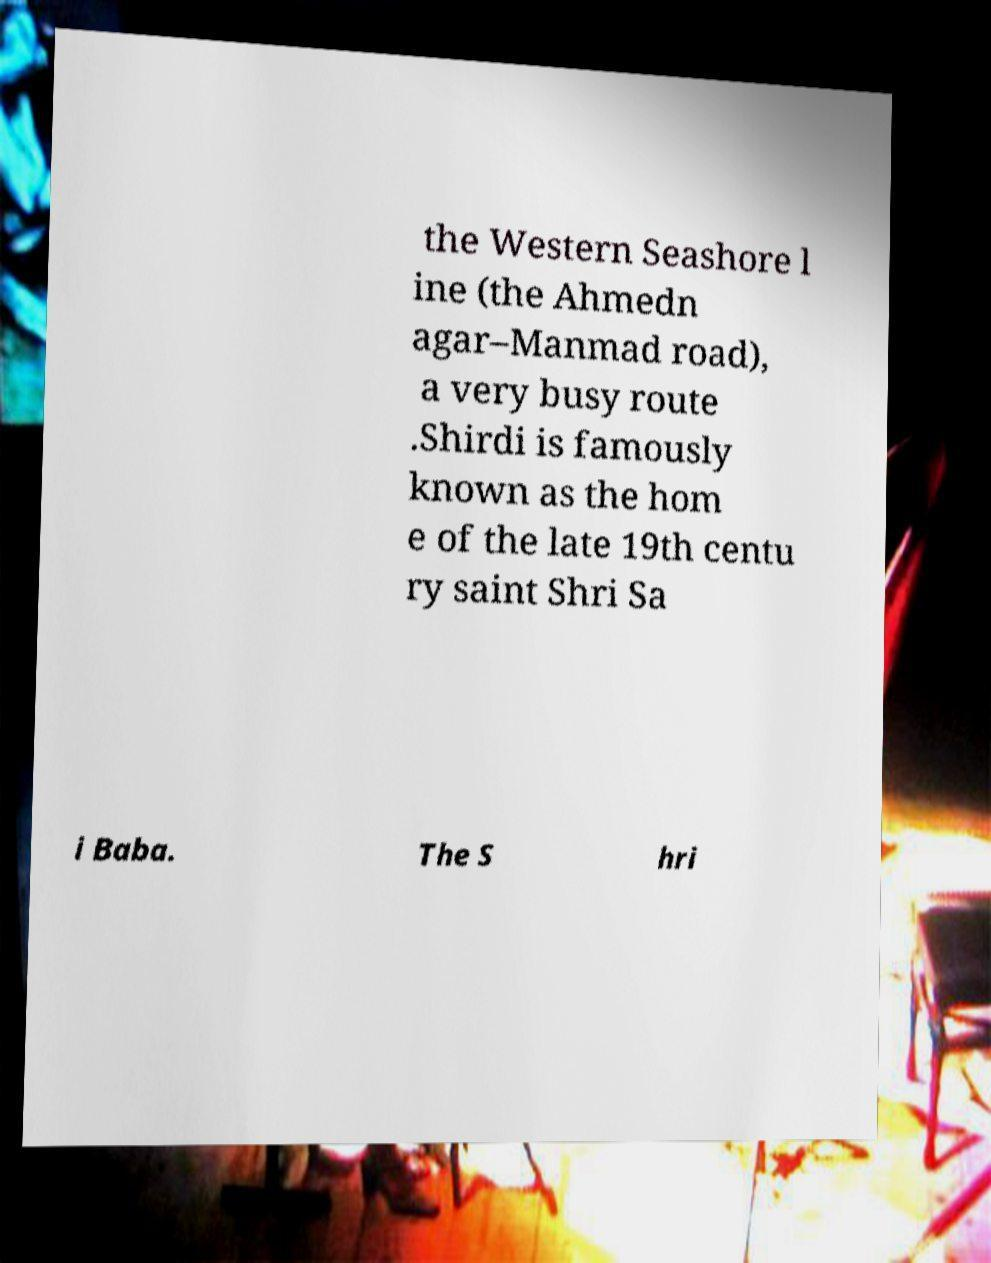There's text embedded in this image that I need extracted. Can you transcribe it verbatim? the Western Seashore l ine (the Ahmedn agar–Manmad road), a very busy route .Shirdi is famously known as the hom e of the late 19th centu ry saint Shri Sa i Baba. The S hri 